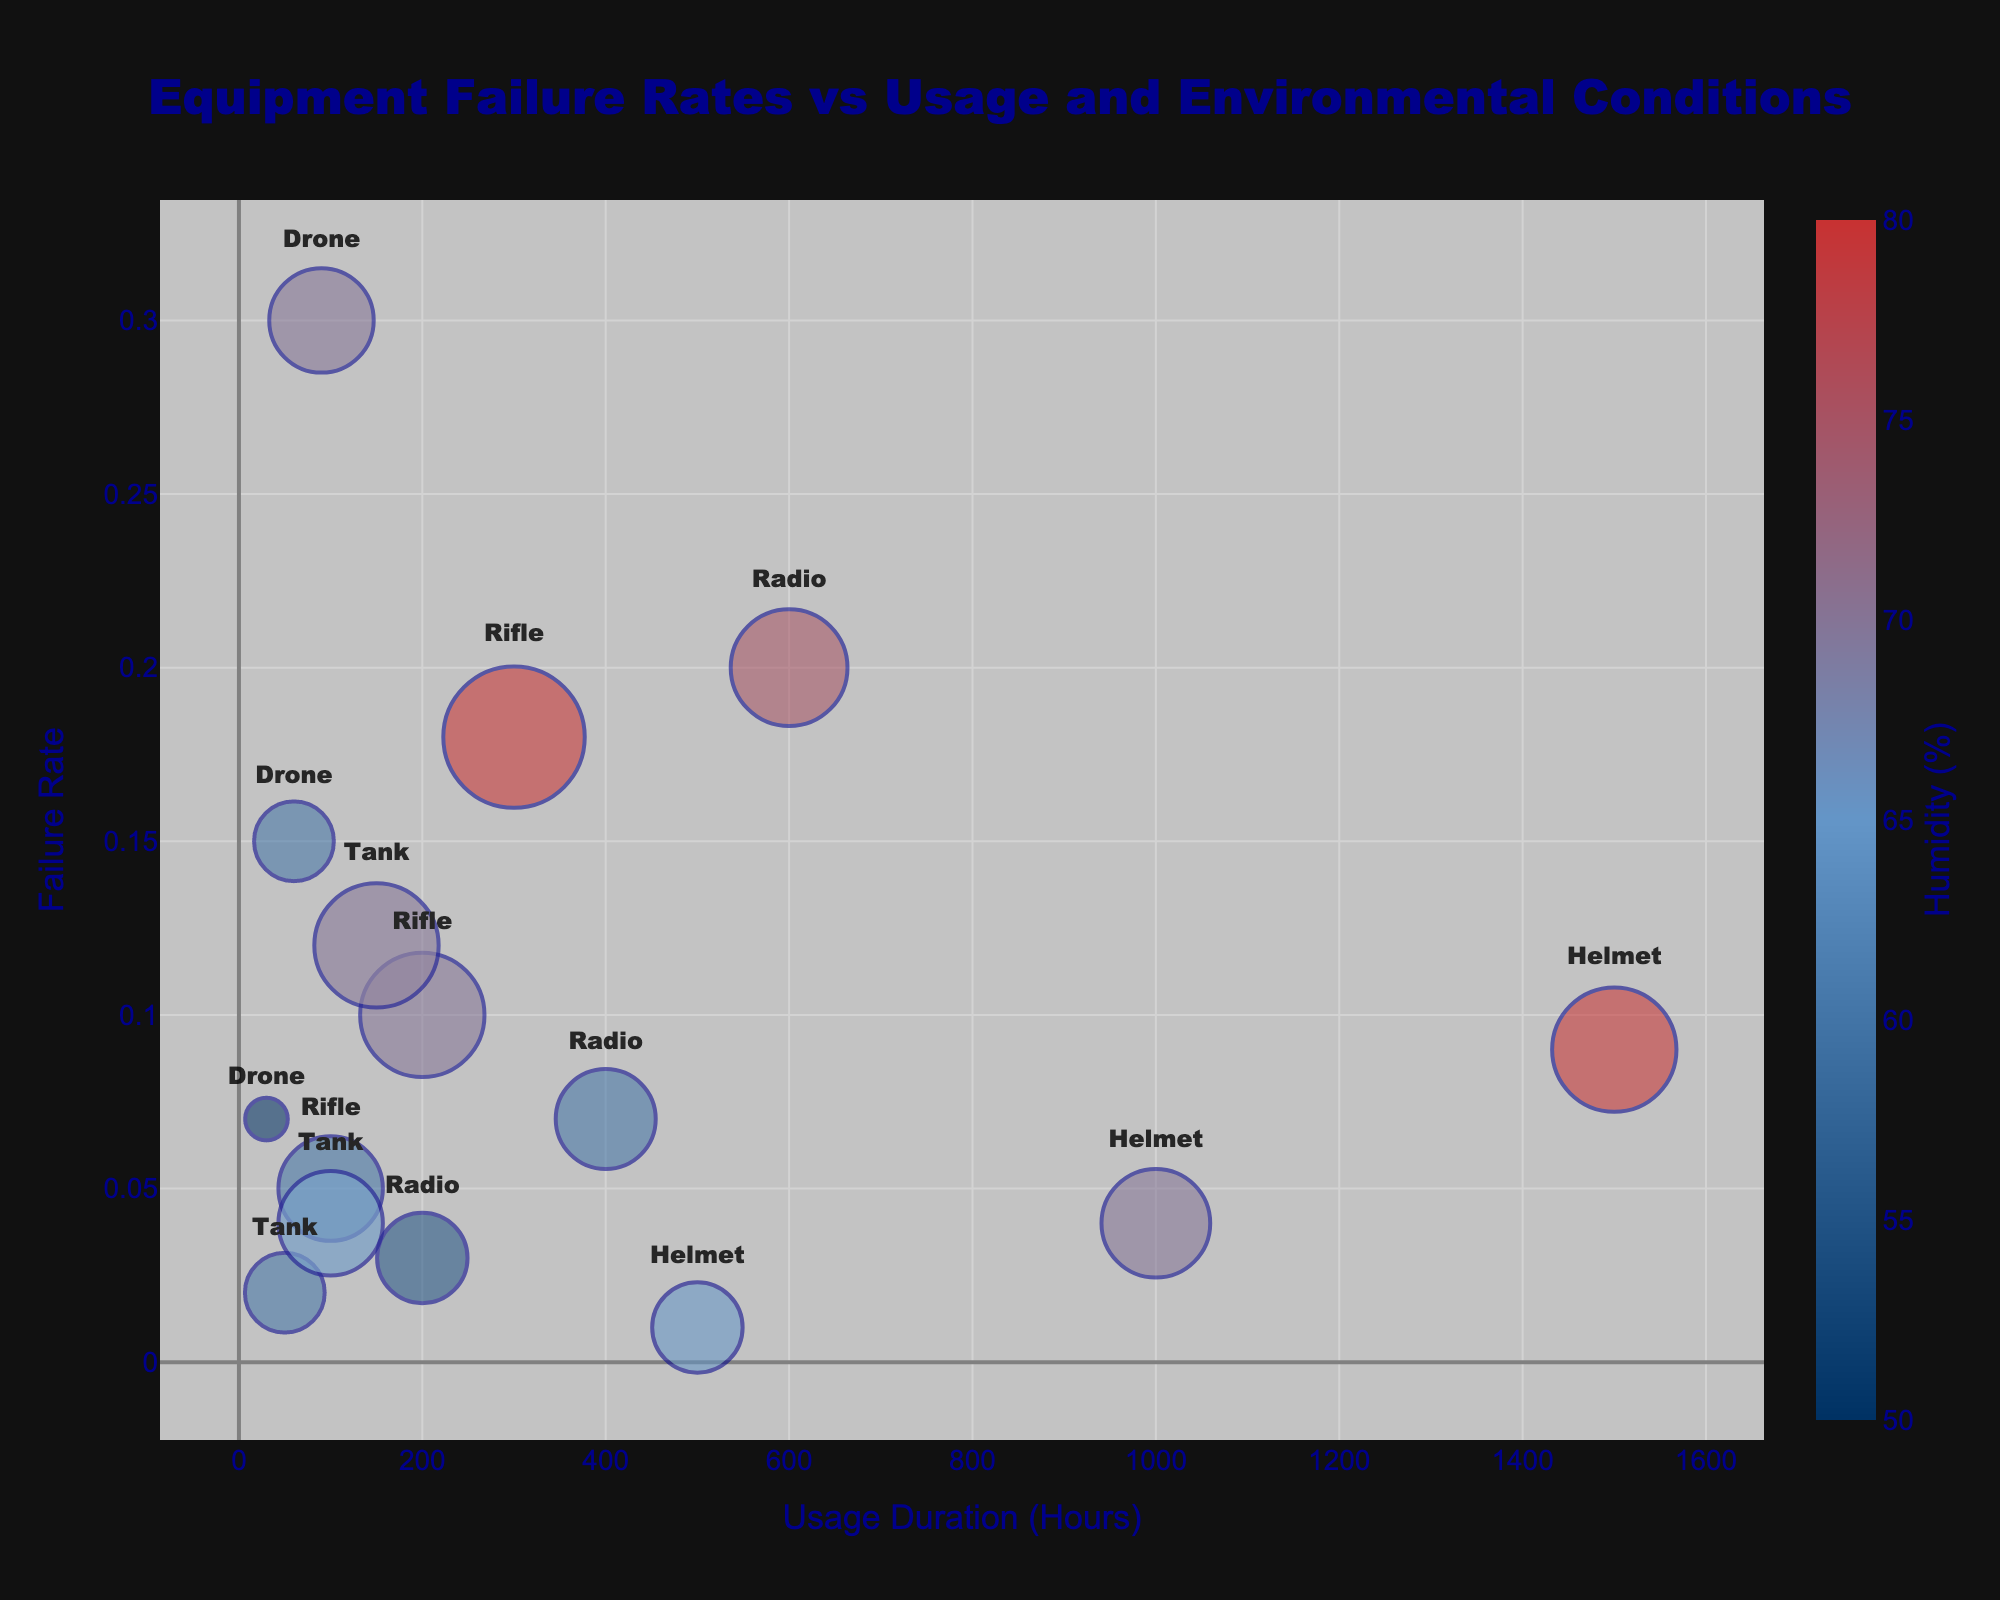What is the title of the figure? The title of the figure is displayed prominently at the top, and it reads "Equipment Failure Rates vs Usage and Environmental Conditions".
Answer: Equipment Failure Rates vs Usage and Environmental Conditions Which equipment has the highest failure rate? By examining the vertical axis for Failure Rate and identifying the highest bubble, it is clear that the Drone has the highest failure rate.
Answer: Drone What is the usage duration and failure rate for the Tank with the smallest bubble? The smallest bubble for the Tank corresponds to a temperature of 20°C. According to the figure, this Tank has a usage duration of 50 hours and a failure rate of 0.02.
Answer: 50 hours, 0.02 Which equipment showed the fastest rate of increase in failure rate with usage duration? Comparing the slopes of the failure rate increase across the different equipment, the Drone shows the fastest increase in failure rate with usage duration, as the bubbles move more rapidly upwards with increasing usage duration.
Answer: Drone How does humidity impact the failure rate of Radios compared to Helmets? By examining the color intensity (which represents humidity) and the vertical position of the Radio and Helmet bubbles, we can see that as humidity increases, the failure rate of Radios rises more significantly compared to Helmets. Helmets have a more gradual increase in failure rate even at higher humidity levels.
Answer: Radios increase more significantly What is the average usage duration of the equipment with a failure rate of 0.1? The figure shows that the Rifle has a failure rate of 0.1 at a usage duration of 200 hours.
Answer: 200 hours At what temperature do the Helmets have their highest recorded failure rate? The Helmets reach their highest recorded failure rate (0.09) at a temperature of 30°C, as indicated by the size of the bubble at this point.
Answer: 30°C Does higher usage duration always correlate with higher failure rates for all equipment types? Observing the trend lines for each equipment type, it is clear that, generally, higher usage duration correlates with higher failure rates, though the rate of increase can vary. For example, while Drones show a steep increase, Tanks show a more gradual increase.
Answer: Yes, but it varies Which equipment experiences the smallest increase in failure rate with increasing Usage Duration from 100 to 150 hours? Comparing the change in failure rates for the equipment between 100 to 150 hours of usage, the Tank experiences the smallest increase, going from 0.04 to 0.12.
Answer: Tank How do the failure rates of Drones compare with Tanks in similar humidity conditions around 70%? By examining bubbles of similar colors (representing around 70% humidity), it’s apparent that Drones exhibit a considerably higher failure rate compared to Tanks when operating under similar humidity conditions.
Answer: Drones are higher 